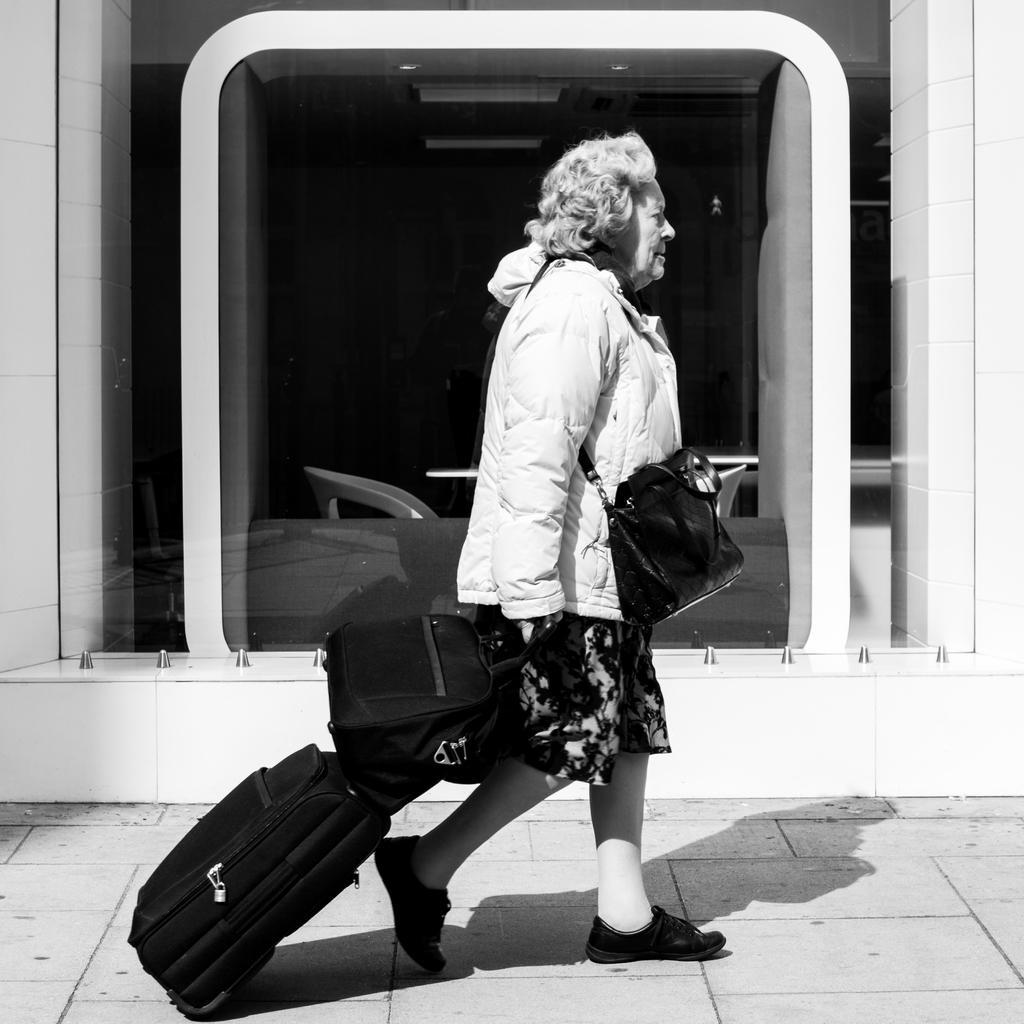Could you give a brief overview of what you see in this image? It's a black and white image in which their is a woman walking with her trolley and a bag. At the back side there is a glass. 